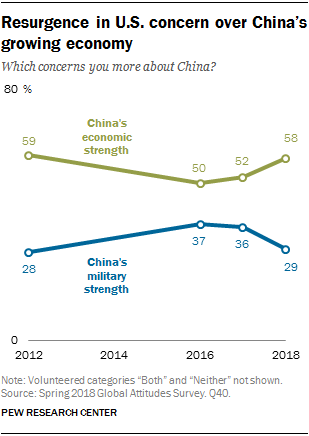Indicate a few pertinent items in this graphic. The sum of all the values is greater than 100. China's economic strength in 2016 was estimated to be approximately 50%. 